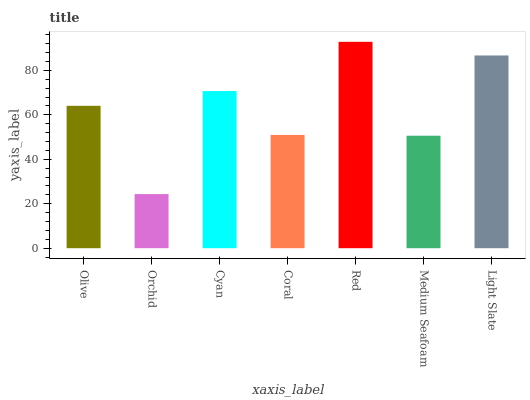Is Orchid the minimum?
Answer yes or no. Yes. Is Red the maximum?
Answer yes or no. Yes. Is Cyan the minimum?
Answer yes or no. No. Is Cyan the maximum?
Answer yes or no. No. Is Cyan greater than Orchid?
Answer yes or no. Yes. Is Orchid less than Cyan?
Answer yes or no. Yes. Is Orchid greater than Cyan?
Answer yes or no. No. Is Cyan less than Orchid?
Answer yes or no. No. Is Olive the high median?
Answer yes or no. Yes. Is Olive the low median?
Answer yes or no. Yes. Is Red the high median?
Answer yes or no. No. Is Medium Seafoam the low median?
Answer yes or no. No. 